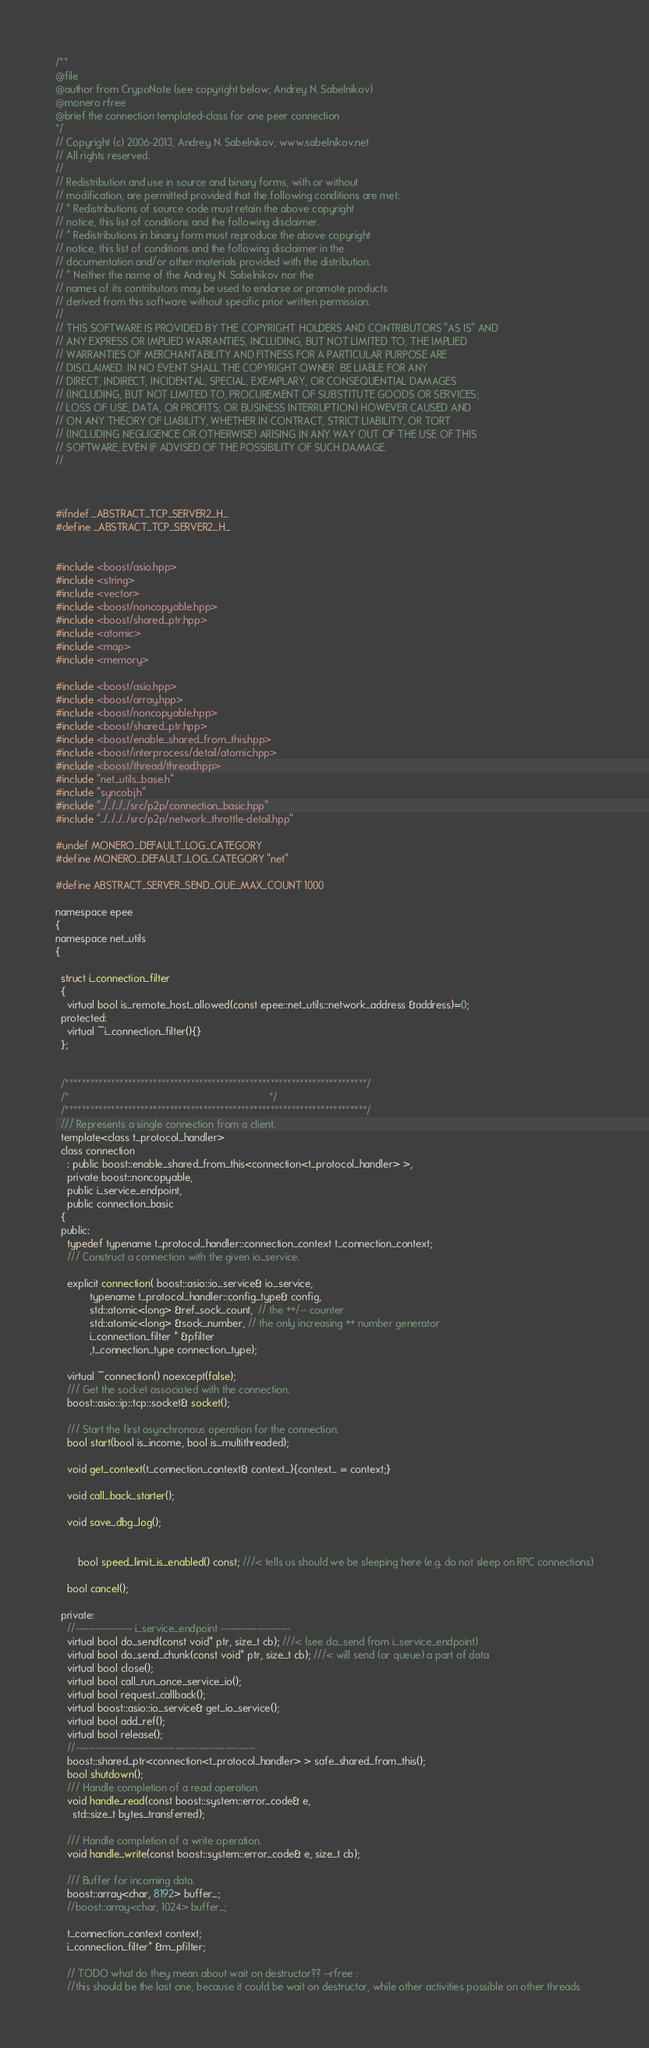Convert code to text. <code><loc_0><loc_0><loc_500><loc_500><_C_>/**
@file
@author from CrypoNote (see copyright below; Andrey N. Sabelnikov)
@monero rfree
@brief the connection templated-class for one peer connection
*/
// Copyright (c) 2006-2013, Andrey N. Sabelnikov, www.sabelnikov.net
// All rights reserved.
// 
// Redistribution and use in source and binary forms, with or without
// modification, are permitted provided that the following conditions are met:
// * Redistributions of source code must retain the above copyright
// notice, this list of conditions and the following disclaimer.
// * Redistributions in binary form must reproduce the above copyright
// notice, this list of conditions and the following disclaimer in the
// documentation and/or other materials provided with the distribution.
// * Neither the name of the Andrey N. Sabelnikov nor the
// names of its contributors may be used to endorse or promote products
// derived from this software without specific prior written permission.
// 
// THIS SOFTWARE IS PROVIDED BY THE COPYRIGHT HOLDERS AND CONTRIBUTORS "AS IS" AND
// ANY EXPRESS OR IMPLIED WARRANTIES, INCLUDING, BUT NOT LIMITED TO, THE IMPLIED
// WARRANTIES OF MERCHANTABILITY AND FITNESS FOR A PARTICULAR PURPOSE ARE
// DISCLAIMED. IN NO EVENT SHALL THE COPYRIGHT OWNER  BE LIABLE FOR ANY
// DIRECT, INDIRECT, INCIDENTAL, SPECIAL, EXEMPLARY, OR CONSEQUENTIAL DAMAGES
// (INCLUDING, BUT NOT LIMITED TO, PROCUREMENT OF SUBSTITUTE GOODS OR SERVICES;
// LOSS OF USE, DATA, OR PROFITS; OR BUSINESS INTERRUPTION) HOWEVER CAUSED AND
// ON ANY THEORY OF LIABILITY, WHETHER IN CONTRACT, STRICT LIABILITY, OR TORT
// (INCLUDING NEGLIGENCE OR OTHERWISE) ARISING IN ANY WAY OUT OF THE USE OF THIS
// SOFTWARE, EVEN IF ADVISED OF THE POSSIBILITY OF SUCH DAMAGE.
// 



#ifndef _ABSTRACT_TCP_SERVER2_H_ 
#define _ABSTRACT_TCP_SERVER2_H_ 


#include <boost/asio.hpp>
#include <string>
#include <vector>
#include <boost/noncopyable.hpp>
#include <boost/shared_ptr.hpp>
#include <atomic>
#include <map>
#include <memory>

#include <boost/asio.hpp>
#include <boost/array.hpp>
#include <boost/noncopyable.hpp>
#include <boost/shared_ptr.hpp>
#include <boost/enable_shared_from_this.hpp>
#include <boost/interprocess/detail/atomic.hpp>
#include <boost/thread/thread.hpp>
#include "net_utils_base.h"
#include "syncobj.h"
#include "../../../../src/p2p/connection_basic.hpp"
#include "../../../../src/p2p/network_throttle-detail.hpp"

#undef MONERO_DEFAULT_LOG_CATEGORY
#define MONERO_DEFAULT_LOG_CATEGORY "net"

#define ABSTRACT_SERVER_SEND_QUE_MAX_COUNT 1000

namespace epee
{
namespace net_utils
{

  struct i_connection_filter
  {
    virtual bool is_remote_host_allowed(const epee::net_utils::network_address &address)=0;
  protected:
    virtual ~i_connection_filter(){}
  };
  

  /************************************************************************/
  /*                                                                      */
  /************************************************************************/
  /// Represents a single connection from a client.
  template<class t_protocol_handler>
  class connection
    : public boost::enable_shared_from_this<connection<t_protocol_handler> >,
    private boost::noncopyable, 
    public i_service_endpoint,
    public connection_basic
  {
  public:
    typedef typename t_protocol_handler::connection_context t_connection_context;
    /// Construct a connection with the given io_service.
   
    explicit connection( boost::asio::io_service& io_service,
			typename t_protocol_handler::config_type& config, 
			std::atomic<long> &ref_sock_count,  // the ++/-- counter 
			std::atomic<long> &sock_number, // the only increasing ++ number generator
			i_connection_filter * &pfilter
			,t_connection_type connection_type);

    virtual ~connection() noexcept(false);
    /// Get the socket associated with the connection.
    boost::asio::ip::tcp::socket& socket();

    /// Start the first asynchronous operation for the connection.
    bool start(bool is_income, bool is_multithreaded);

    void get_context(t_connection_context& context_){context_ = context;}

    void call_back_starter();
    
    void save_dbg_log();


		bool speed_limit_is_enabled() const; ///< tells us should we be sleeping here (e.g. do not sleep on RPC connections)

    bool cancel();
    
  private:
    //----------------- i_service_endpoint ---------------------
    virtual bool do_send(const void* ptr, size_t cb); ///< (see do_send from i_service_endpoint)
    virtual bool do_send_chunk(const void* ptr, size_t cb); ///< will send (or queue) a part of data
    virtual bool close();
    virtual bool call_run_once_service_io();
    virtual bool request_callback();
    virtual boost::asio::io_service& get_io_service();
    virtual bool add_ref();
    virtual bool release();
    //------------------------------------------------------
    boost::shared_ptr<connection<t_protocol_handler> > safe_shared_from_this();
    bool shutdown();
    /// Handle completion of a read operation.
    void handle_read(const boost::system::error_code& e,
      std::size_t bytes_transferred);

    /// Handle completion of a write operation.
    void handle_write(const boost::system::error_code& e, size_t cb);

    /// Buffer for incoming data.
    boost::array<char, 8192> buffer_;
    //boost::array<char, 1024> buffer_;

    t_connection_context context;
    i_connection_filter* &m_pfilter;

	// TODO what do they mean about wait on destructor?? --rfree :
    //this should be the last one, because it could be wait on destructor, while other activities possible on other threads</code> 